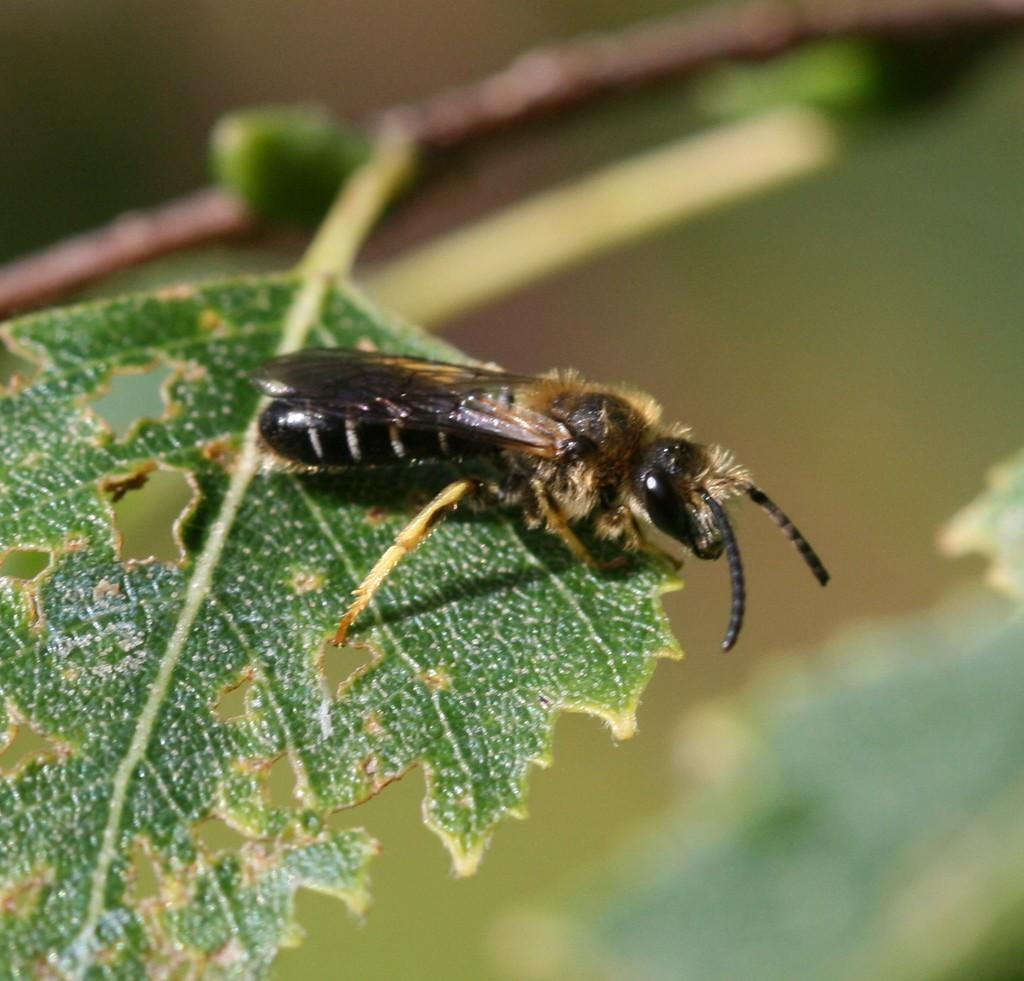What insect is present on the leaf in the image? There is a sawfly on a leaf in the image. What part of the plant is visible in the image? There is a stem in the image. How would you describe the background of the image? The background of the image is blurred. What type of stocking can be seen hanging from the tree in the image? There is no stocking present in the image; it features a sawfly on a leaf and a blurred background. 